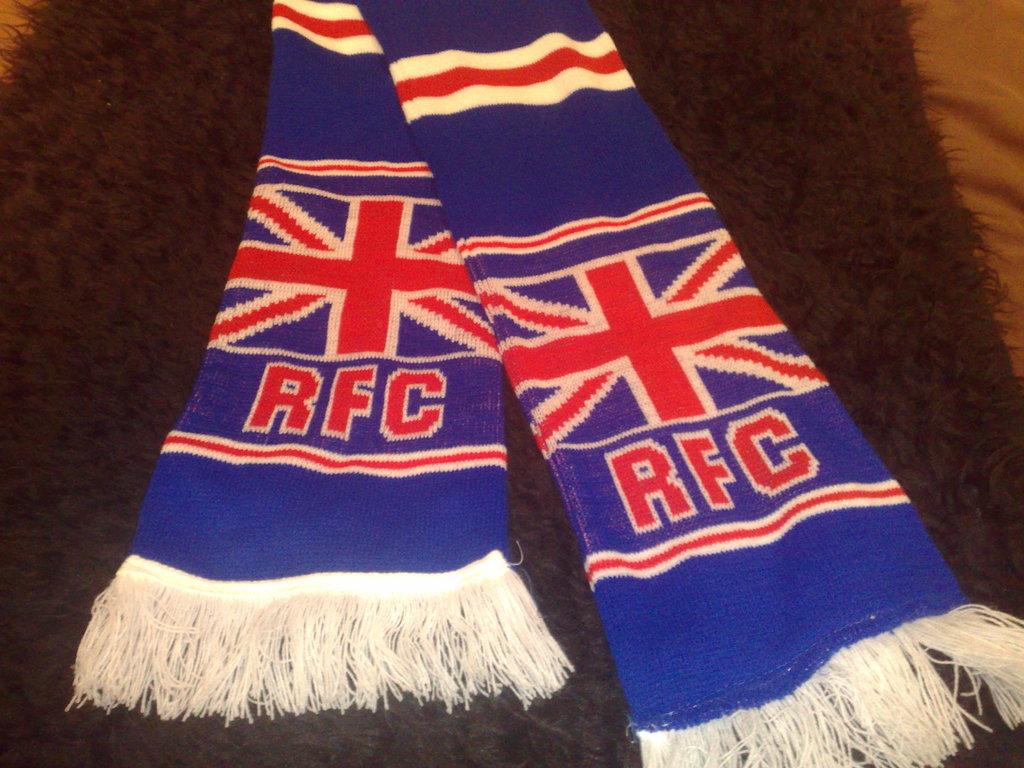Which soccer club is this scarf for?
Keep it short and to the point. Rfc. What are the three letters on the scarf?
Provide a succinct answer. Rfc. 